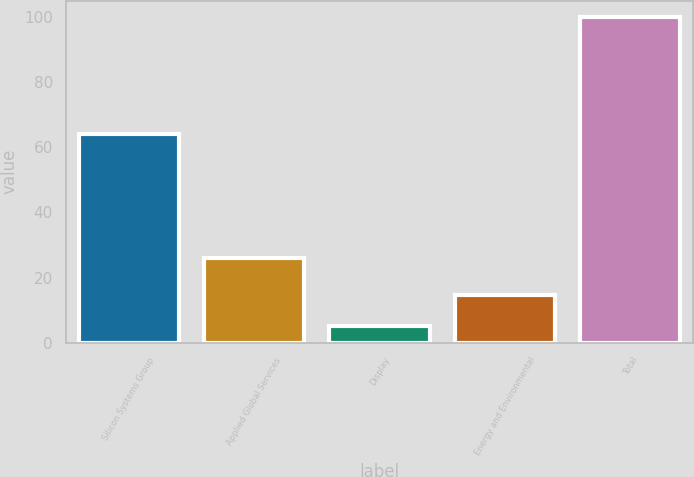Convert chart to OTSL. <chart><loc_0><loc_0><loc_500><loc_500><bar_chart><fcel>Silicon Systems Group<fcel>Applied Global Services<fcel>Display<fcel>Energy and Environmental<fcel>Total<nl><fcel>64<fcel>26<fcel>5<fcel>14.5<fcel>100<nl></chart> 